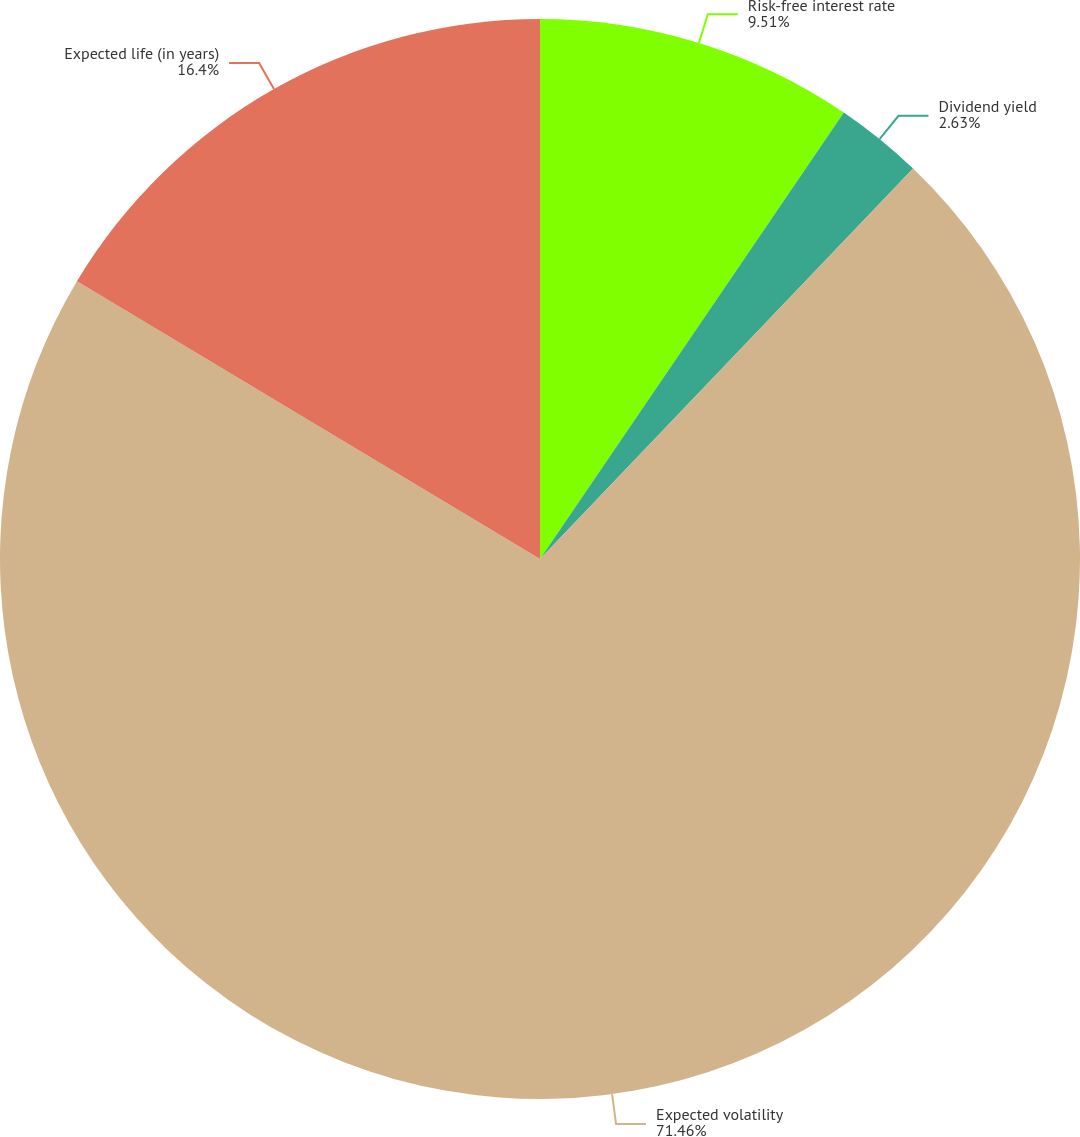Convert chart to OTSL. <chart><loc_0><loc_0><loc_500><loc_500><pie_chart><fcel>Risk-free interest rate<fcel>Dividend yield<fcel>Expected volatility<fcel>Expected life (in years)<nl><fcel>9.51%<fcel>2.63%<fcel>71.46%<fcel>16.4%<nl></chart> 